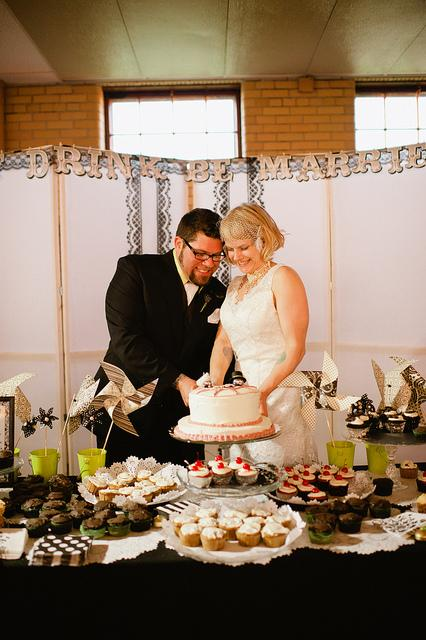What are the two touching? cake 